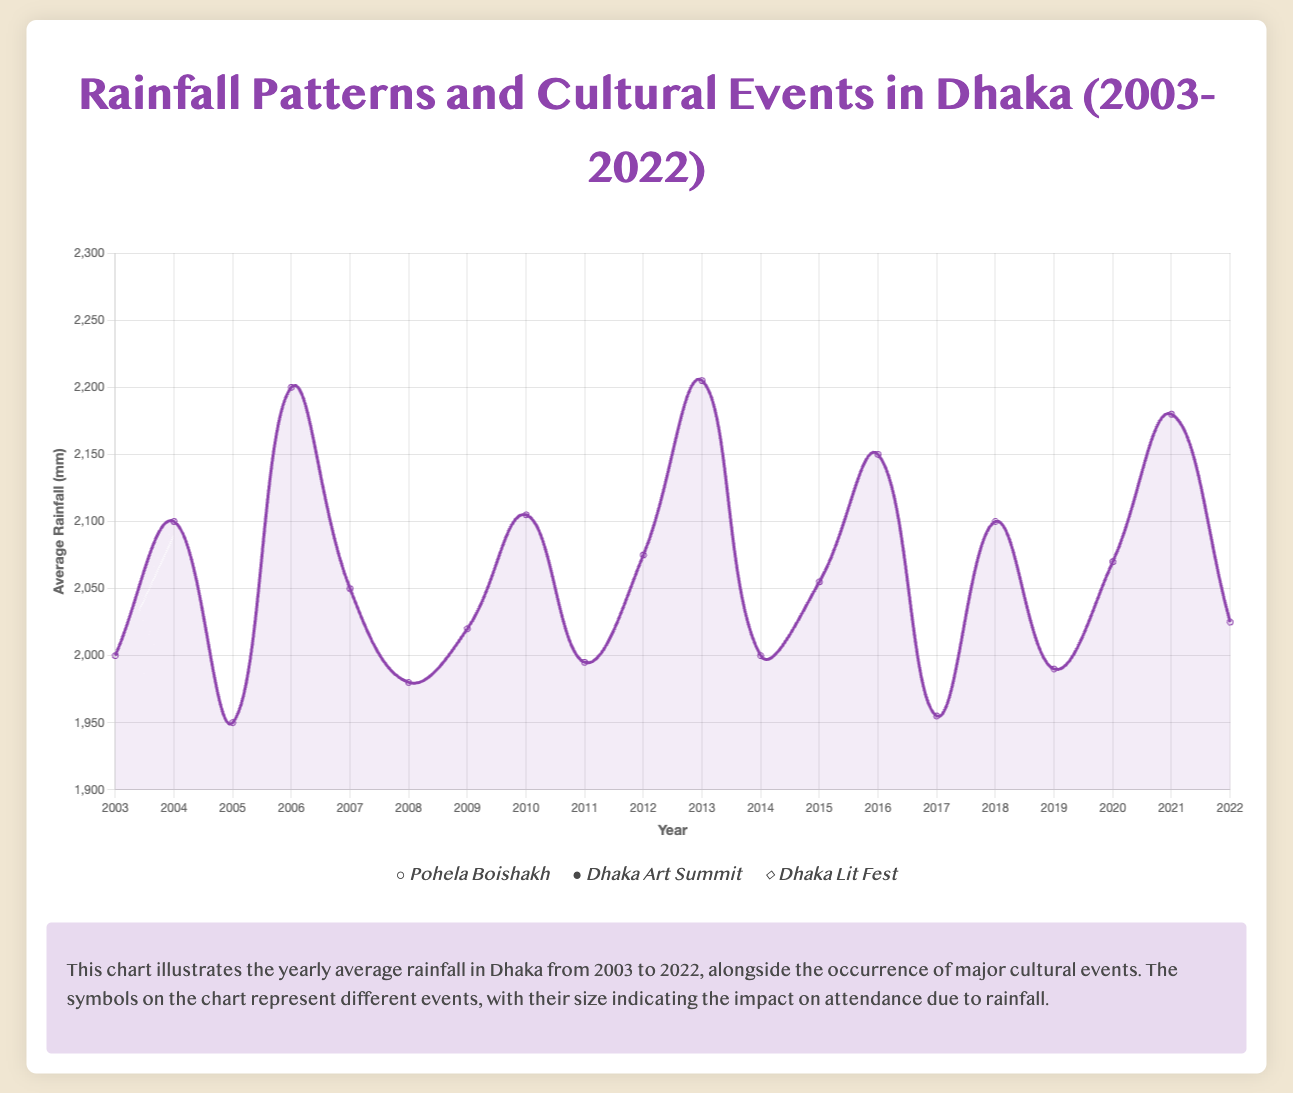What's the trend in average rainfall from 2003 to 2022? Observing the line plot, note the changes in yearly average rainfall values between 2003 and 2022. The overall trend appears to be relatively stable with some fluctuations, without a significant upward or downward trend.
Answer: Relatively stable with fluctuations How does the average rainfall in 2006 compare to 2013? Identify the data points for the years 2006 and 2013 and compare their values. The figure shows that average rainfall in 2006 is 2200 mm and in 2013 is 2205 mm.
Answer: 2013 is slightly higher than 2006 What was the highest average rainfall recorded, and in which year? Look for the peak in the line plot between 2003 and 2022 to determine the highest rainfall. The highest value is around 2205 mm, recorded in 2013.
Answer: 2205 mm in 2013 How often did the Dhaka Lit Fest event have a high impact on attendance between 2003 and 2022? Refer to the visual representation where the impact of each event is indicated. Dhaka Lit Fest had a high impact in the years 2006, 2012, and 2016, totaling 3 occurrences.
Answer: 3 times Compare rainfall in years with high-impact Dhaka Art Summit to those with moderate impact. How many years had higher rainfall than their counterparts? Identify years with high impact from Dhaka Art Summit and moderate impact years, then compare the rainfall values. High impact years 2006, 2019 vs moderate years like 2003, 2005, 2007, 2009, 2011, 2014, 2015, 2018, 2020, 2021, 2022 show that 2019 had higher rainfall compared to most moderate years.
Answer: 1 year (2019) had higher rainfall than many moderate years What is the impact of rainfall on Pohela Boishakh across the years? Check each year for the symbol representing Pohela Boishakh, noting the stated impact level. Generally, Pohela Boishakh shows no impact most years, with exceptions in 2015 (low), 2013 (low), and 2018 (moderate).
Answer: Minimal impact overall What's the average value of rainfall for the first and last five years of the graph? Calculate the average rainfall for years 2003-2007 and 2018-2022. Sum totals (2000+2100+1950+2200+2050)/5 and (2100+1990+2070+2180+2025)/5. The averages are 2060 mm for 2003-2007 and 2073 mm for 2018-2022.
Answer: 2060 mm for 2003-2007, 2073 mm for 2018-2022 What is the relationship between the amount of rainfall and the impact on all cultural events over the years? Examine each year where high, moderate, or low impacts are recorded and compare it with rainfall data in those years. High-impact Dhaka Lit Fest often coincides with slightly higher rainfall years.
Answer: Higher impacts generally correlate with higher rainfall In which years did Pohela Boishakh experience some rainfall impact and how does it visually compare to other events? Identify and differentiate years when Pohela Boishakh had non-zero impact and compare visual markers/symbols sizes for impact severity compared to other events. 2013, 2018, and 2021 had impacts, which are generally smaller in markers compared to high-impact Dhaka Art Summit/Lit Fest years.
Answer: 2013, 2018, 2021 with smaller visual impact symbols compared to others Is there a year where all three cultural events experienced the low to high impacts and what does that reveal about the rainfall that year? Check for the year with marks for all three events, reviewing impact levels and overall rainfall data for that year. No single year hosts all three events with non-none impacts, indicating spread-out impact years.
Answer: No such single year exists 